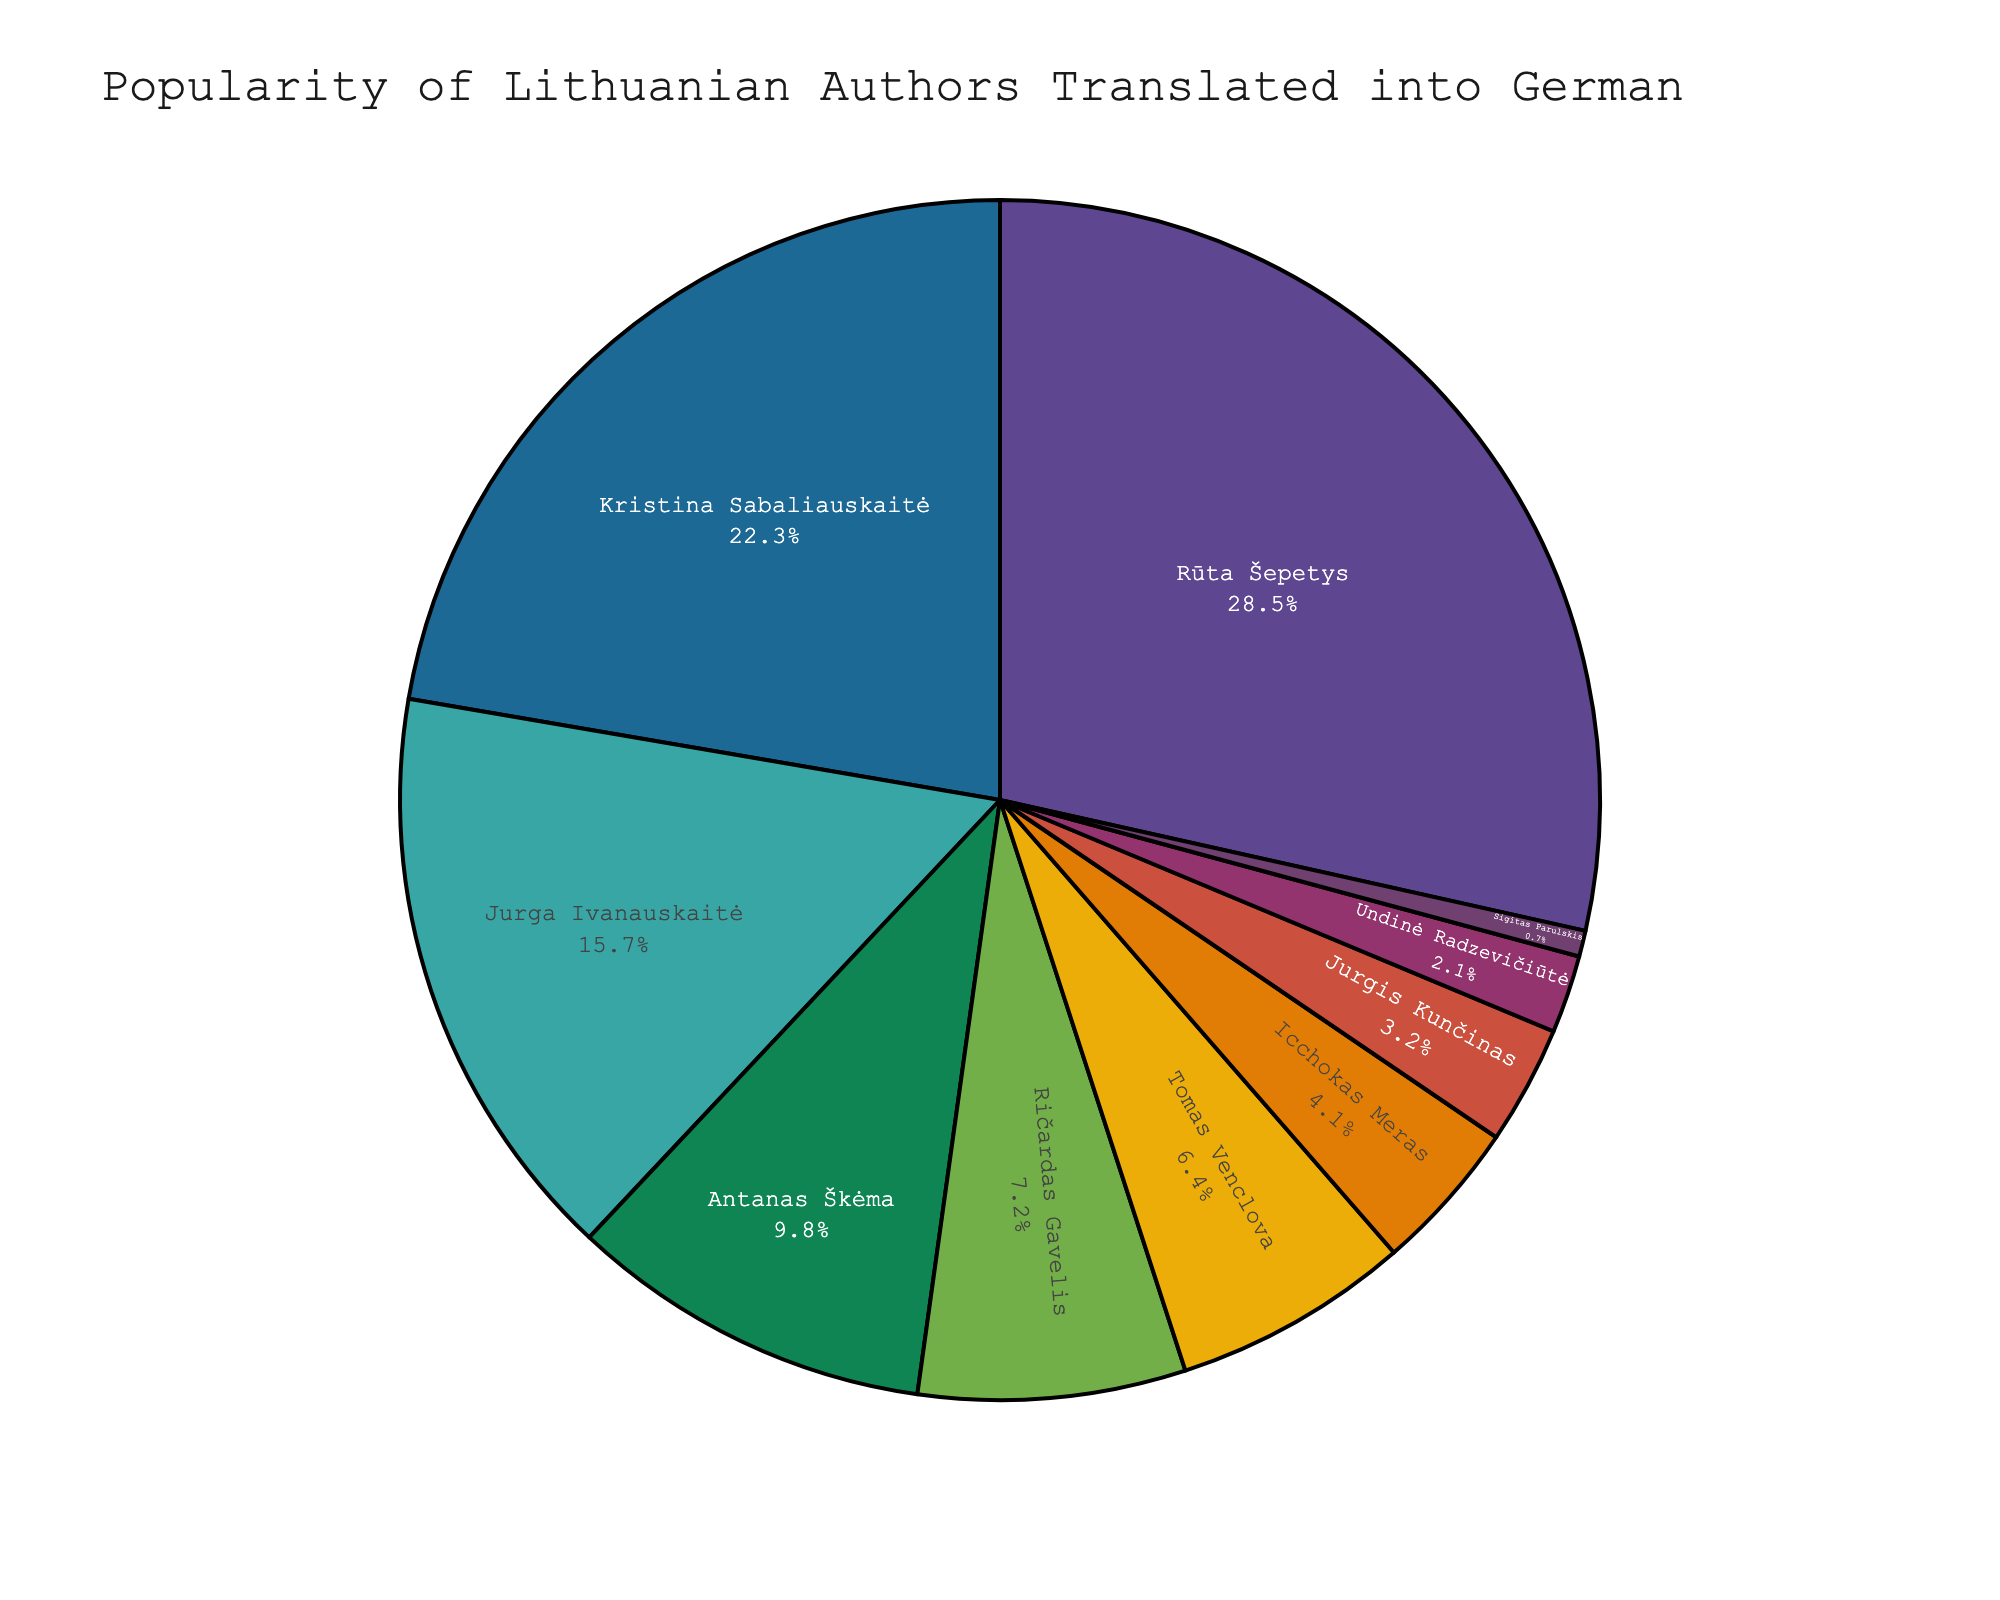what percentage of book sales come from the top three authors? The top three authors by percentage are Rūta Šepetys (28.5%), Kristina Sabaliauskaitė (22.3%), and Jurga Ivanauskaitė (15.7%). Summing these percentages gives 28.5 + 22.3 + 15.7 = 66.5
Answer: 66.5 Which author has the highest percentage of book sales, and what is that percentage? By looking at the figure, Rūta Šepetys has the highest percentage of book sales, which is 28.5%.
Answer: Rūta Šepetys, 28.5% Is there any author with less than 1% of the book sales? According to the figure, Sigitas Parulskis has 0.7% of the book sales, which is less than 1%.
Answer: Yes, Sigitas Parulskis How much more popular is Jurga Ivanauskaitė compared to Antanas Škėma in terms of book sales percentage? Jurga Ivanauskaitė has 15.7%, and Antanas Škėma has 9.8%. The difference is 15.7 - 9.8 = 5.9.
Answer: 5.9 What is the combined percentage of book sales for Ričardas Gavelis and Tomas Venclova? Ričardas Gavelis has 7.2% and Tomas Venclova has 6.4%. Adding these gives 7.2 + 6.4 = 13.6.
Answer: 13.6 Which three authors are the least popular by book sales, and what are their percentages? The three least popular authors are Sigitas Parulskis (0.7%), Undinė Radzevičiūtė (2.1%), and Jurgis Kunčinas (3.2%).
Answer: Sigitas Parulskis (0.7%), Undinė Radzevičiūtė (2.1%), Jurgis Kunčinas (3.2%) How much more percentage of book sales does Kristina Sabaliauskaitė have compared to Icchokas Meras? Kristina Sabaliauskaitė has 22.3%, and Icchokas Meras has 4.1%. The difference is 22.3 - 4.1 = 18.2.
Answer: 18.2 How many authors have a sales percentage of 10% or higher? Rūta Šepetys (28.5%), Kristina Sabaliauskaitė (22.3%), and Jurga Ivanauskaitė (15.7%) have percentages higher than 10%.
Answer: 3 What is the median sales percentage value? Ordering the percentages: 0.7, 2.1, 3.2, 4.1, 6.4, 7.2, 9.8, 15.7, 22.3, 28.5. For 10 values, the median is the average of the 5th and 6th values: (6.4 + 7.2) / 2 = 6.8.
Answer: 6.8 